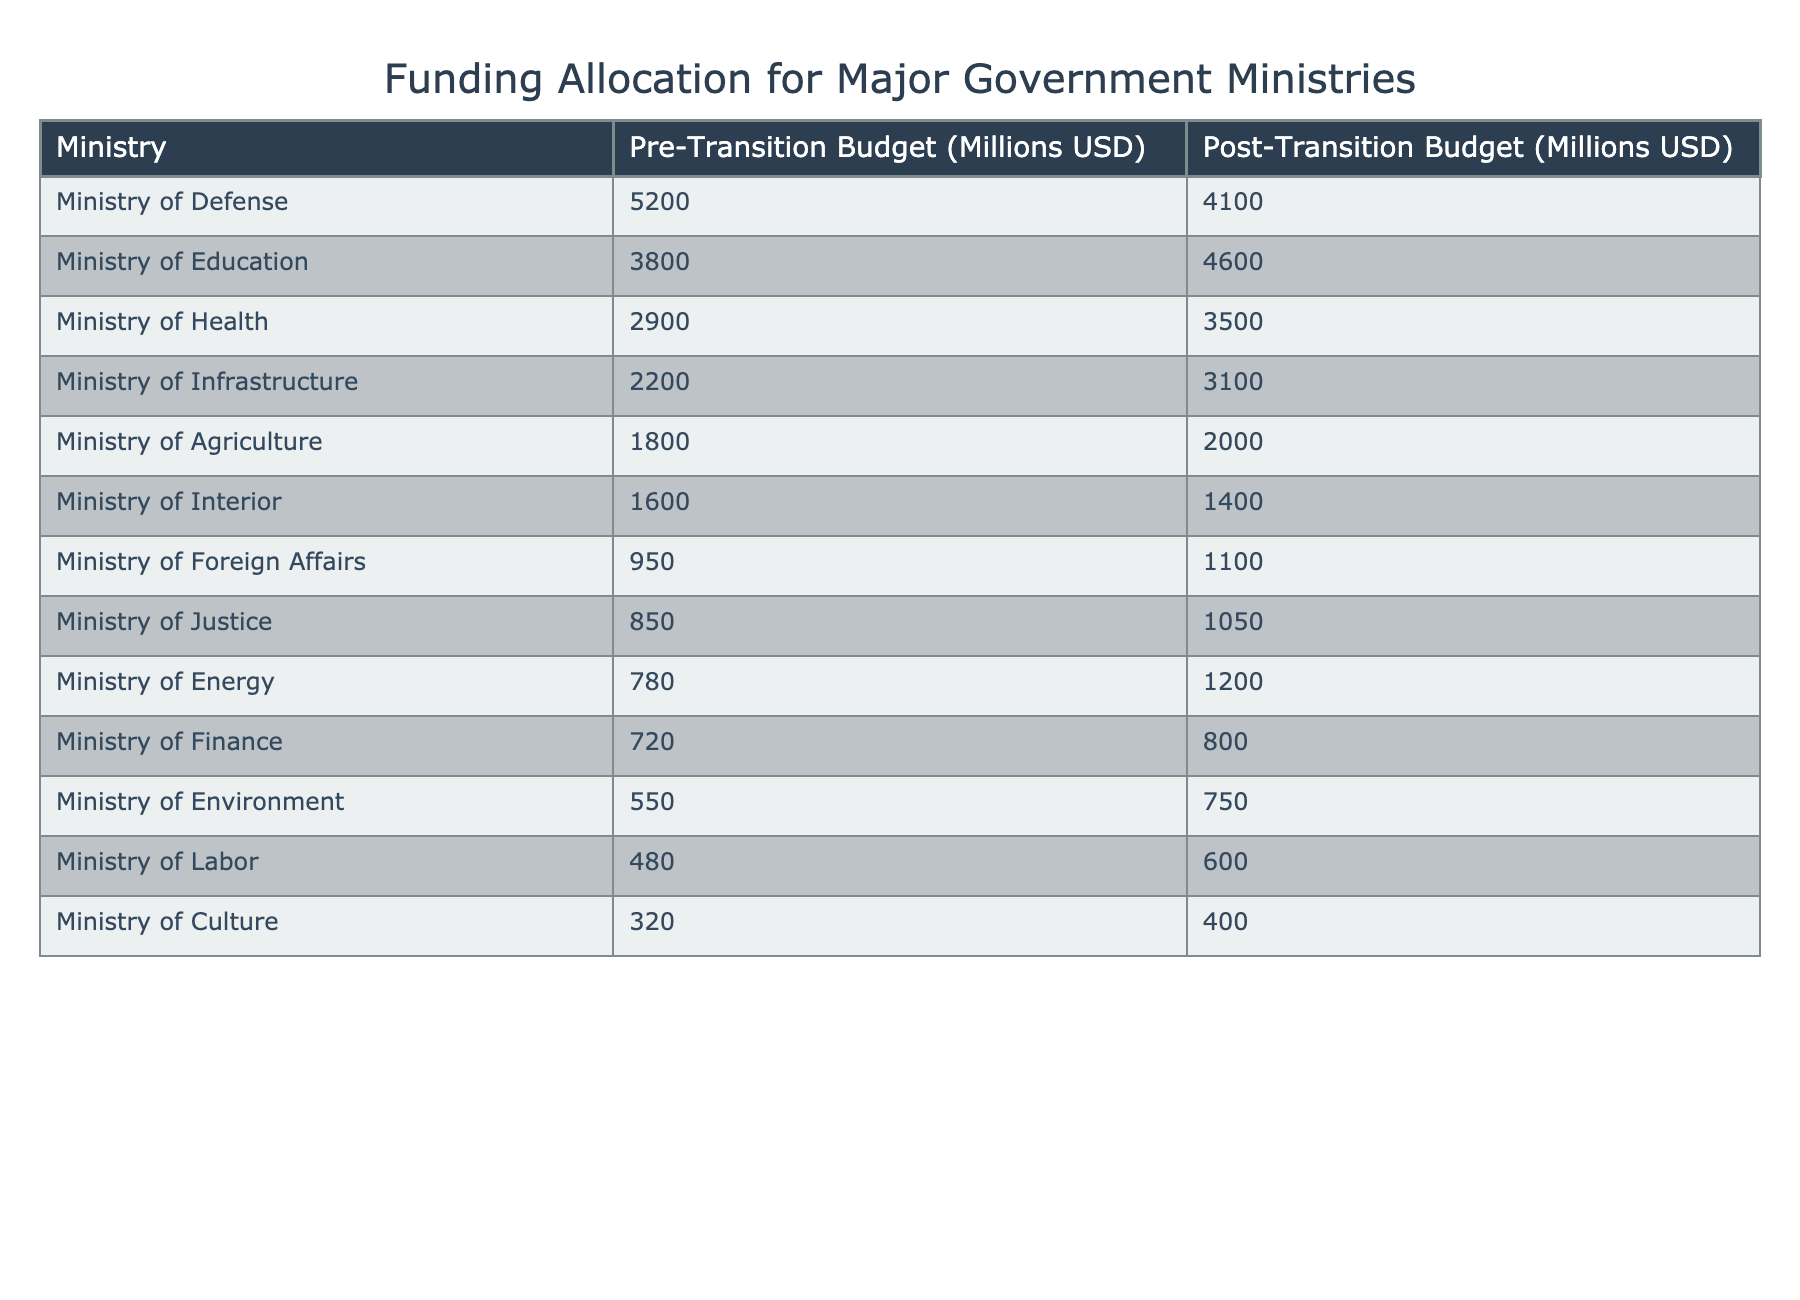What is the budget allocated to the Ministry of Health post-transition? The table shows the budget for the Ministry of Health post-transition as 3500 million USD.
Answer: 3500 million USD How much did the funding for the Ministry of Defense decrease after the transition? The pre-transition budget for the Ministry of Defense was 5200 million USD and the post-transition budget is 4100 million USD. The decrease is 5200 - 4100 = 1100 million USD.
Answer: 1100 million USD Which ministry received the highest budget post-transition? Looking at the post-transition budgets, the Ministry of Defense received 4100 million USD, which is higher than any other ministry.
Answer: Ministry of Defense Was the funding for the Ministry of Interior increased or decreased post-transition? The pre-transition budget for the Ministry of Interior was 1600 million USD and the post-transition budget is 1400 million USD. This shows a decrease.
Answer: Decreased What is the average budget allocated to all ministries post-transition? Adding the post-transition budgets: 4100 + 4600 + 3500 + 3100 + 2000 + 1400 + 1100 + 1050 + 1200 + 800 + 750 + 600 + 400 =  19700 million USD. There are 13 ministries, so the average is 19700 / 13 = approximately 1515.38 million USD.
Answer: 1515.38 million USD Which ministry saw the smallest increase in budget after the transition? The Ministry of Agriculture saw an increase from 1800 million USD to 2000 million USD, which is an increase of 200 million USD. No other ministry had a smaller increase.
Answer: Ministry of Agriculture What is the total budget allocated to the Ministries of Education and Health post-transition? The post-transition budget for Education is 4600 million USD and for Health is 3500 million USD. The total is 4600 + 3500 = 8100 million USD.
Answer: 8100 million USD Is the funding for the Ministry of Energy higher or lower than that of the Ministry of Foreign Affairs post-transition? The Ministry of Energy's post-transition budget is 1200 million USD, while the Ministry of Foreign Affairs is 1100 million USD. Since 1200 is greater than 1100, it's higher.
Answer: Higher How does the post-transition budget of the Ministry of Culture compare to the pre-transition budget? The pre-transition budget for the Ministry of Culture was 320 million USD and the post-transition budget is 400 million USD. It shows an increase of 80 million USD.
Answer: Increased 